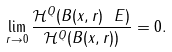Convert formula to latex. <formula><loc_0><loc_0><loc_500><loc_500>\lim _ { r \rightarrow 0 } \frac { \mathcal { H } ^ { Q } ( B ( x , r ) \ E ) } { \mathcal { H } ^ { Q } ( B ( x , r ) ) } = 0 .</formula> 